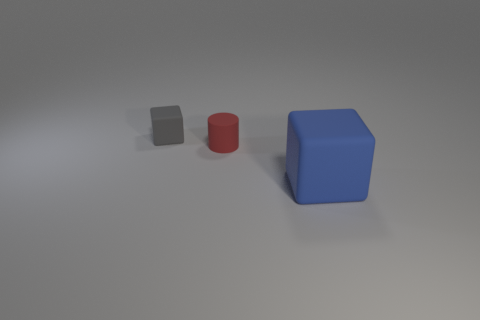What number of red objects are the same size as the gray rubber cube?
Offer a very short reply. 1. There is a small cylinder that is the same material as the blue block; what color is it?
Your answer should be very brief. Red. Is the number of tiny gray rubber objects that are left of the small gray object less than the number of large blue blocks?
Offer a very short reply. Yes. What is the shape of the big object that is made of the same material as the small cylinder?
Make the answer very short. Cube. What number of matte objects are either large blue cubes or tiny purple objects?
Provide a succinct answer. 1. Is the number of cubes that are behind the gray rubber block the same as the number of tiny purple matte blocks?
Your response must be concise. Yes. There is a matte cube that is behind the big block; does it have the same color as the small matte cylinder?
Keep it short and to the point. No. What is the thing that is both in front of the gray block and behind the big blue matte object made of?
Provide a succinct answer. Rubber. Is there a matte thing that is in front of the small rubber object behind the red matte object?
Provide a short and direct response. Yes. Do the red cylinder and the large blue thing have the same material?
Make the answer very short. Yes. 